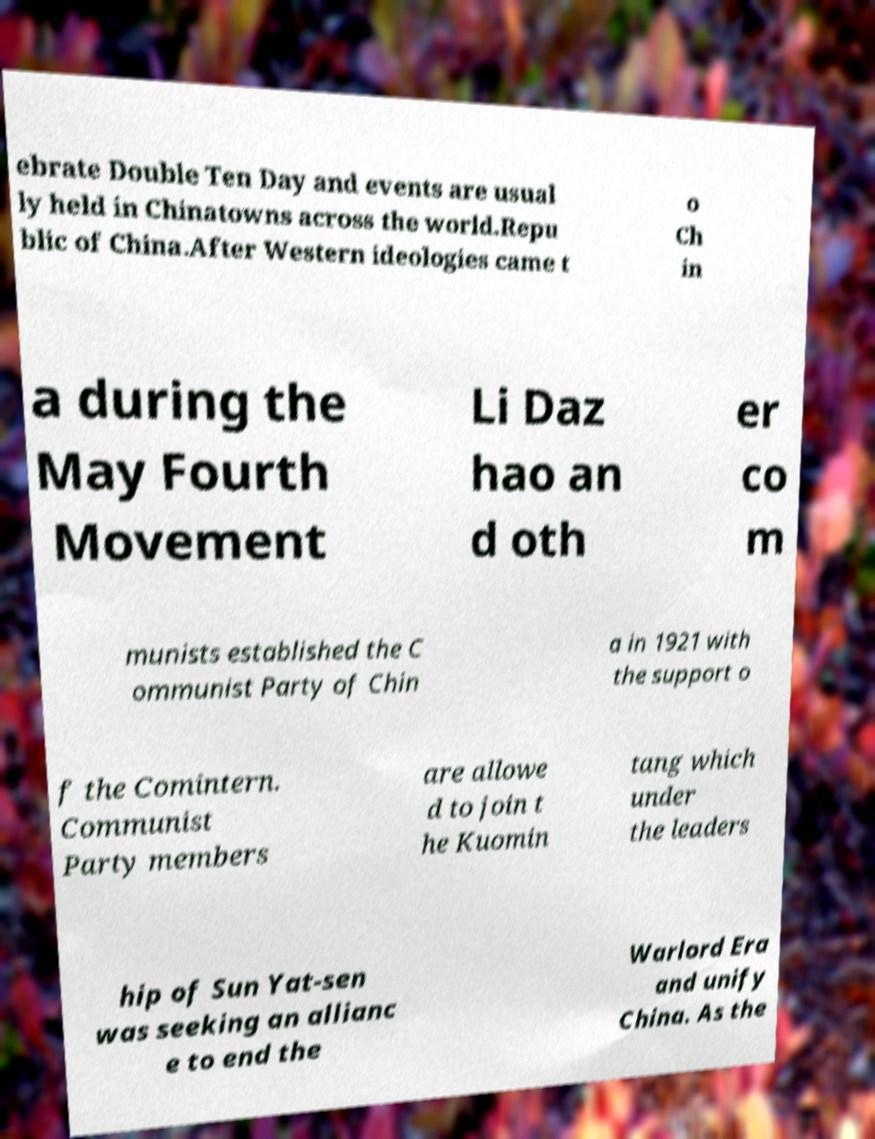Can you read and provide the text displayed in the image?This photo seems to have some interesting text. Can you extract and type it out for me? ebrate Double Ten Day and events are usual ly held in Chinatowns across the world.Repu blic of China.After Western ideologies came t o Ch in a during the May Fourth Movement Li Daz hao an d oth er co m munists established the C ommunist Party of Chin a in 1921 with the support o f the Comintern. Communist Party members are allowe d to join t he Kuomin tang which under the leaders hip of Sun Yat-sen was seeking an allianc e to end the Warlord Era and unify China. As the 